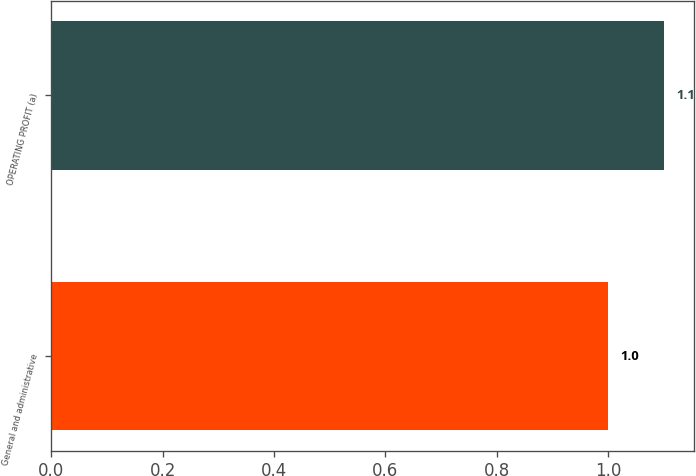<chart> <loc_0><loc_0><loc_500><loc_500><bar_chart><fcel>General and administrative<fcel>OPERATING PROFIT (a)<nl><fcel>1<fcel>1.1<nl></chart> 